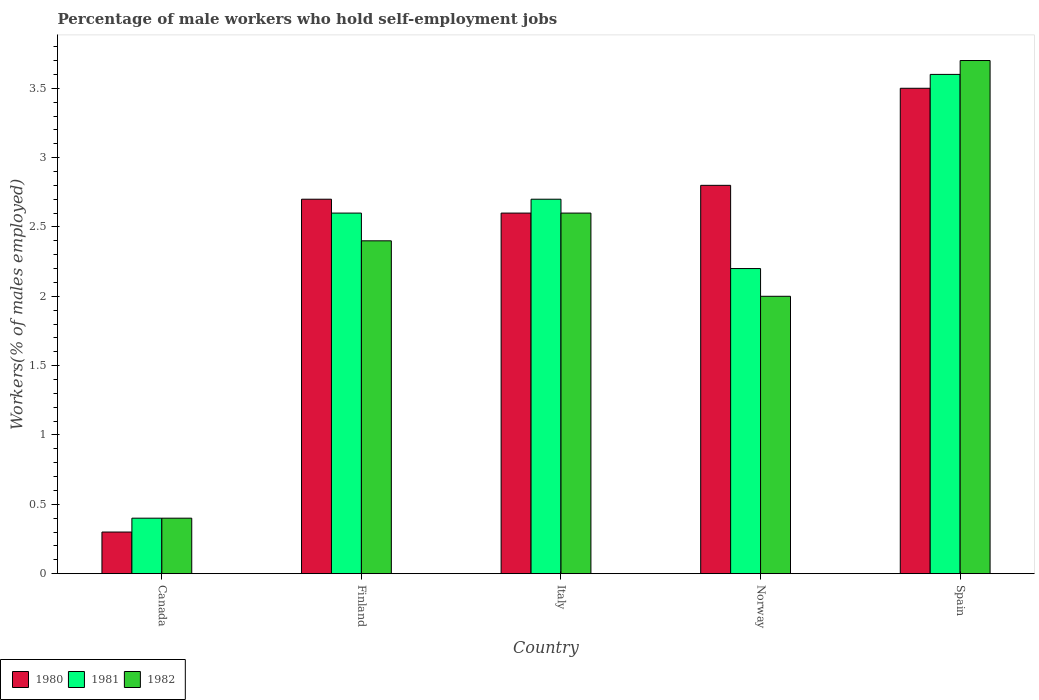How many different coloured bars are there?
Your answer should be compact. 3. Are the number of bars on each tick of the X-axis equal?
Your response must be concise. Yes. How many bars are there on the 4th tick from the left?
Ensure brevity in your answer.  3. What is the percentage of self-employed male workers in 1981 in Canada?
Ensure brevity in your answer.  0.4. Across all countries, what is the maximum percentage of self-employed male workers in 1982?
Give a very brief answer. 3.7. Across all countries, what is the minimum percentage of self-employed male workers in 1982?
Offer a very short reply. 0.4. In which country was the percentage of self-employed male workers in 1981 minimum?
Ensure brevity in your answer.  Canada. What is the total percentage of self-employed male workers in 1980 in the graph?
Provide a succinct answer. 11.9. What is the difference between the percentage of self-employed male workers in 1981 in Canada and that in Spain?
Offer a terse response. -3.2. What is the difference between the percentage of self-employed male workers in 1981 in Spain and the percentage of self-employed male workers in 1982 in Italy?
Provide a succinct answer. 1. What is the average percentage of self-employed male workers in 1981 per country?
Provide a succinct answer. 2.3. What is the difference between the percentage of self-employed male workers of/in 1981 and percentage of self-employed male workers of/in 1982 in Italy?
Ensure brevity in your answer.  0.1. In how many countries, is the percentage of self-employed male workers in 1981 greater than 1.5 %?
Provide a short and direct response. 4. What is the ratio of the percentage of self-employed male workers in 1981 in Italy to that in Norway?
Make the answer very short. 1.23. Is the percentage of self-employed male workers in 1982 in Canada less than that in Norway?
Offer a very short reply. Yes. Is the difference between the percentage of self-employed male workers in 1981 in Italy and Norway greater than the difference between the percentage of self-employed male workers in 1982 in Italy and Norway?
Provide a succinct answer. No. What is the difference between the highest and the second highest percentage of self-employed male workers in 1981?
Make the answer very short. -0.9. What is the difference between the highest and the lowest percentage of self-employed male workers in 1981?
Give a very brief answer. 3.2. What does the 1st bar from the left in Italy represents?
Provide a short and direct response. 1980. Are all the bars in the graph horizontal?
Make the answer very short. No. How many countries are there in the graph?
Keep it short and to the point. 5. What is the difference between two consecutive major ticks on the Y-axis?
Your answer should be very brief. 0.5. Does the graph contain any zero values?
Your answer should be compact. No. Where does the legend appear in the graph?
Provide a short and direct response. Bottom left. How are the legend labels stacked?
Keep it short and to the point. Horizontal. What is the title of the graph?
Your answer should be very brief. Percentage of male workers who hold self-employment jobs. What is the label or title of the Y-axis?
Keep it short and to the point. Workers(% of males employed). What is the Workers(% of males employed) of 1980 in Canada?
Make the answer very short. 0.3. What is the Workers(% of males employed) in 1981 in Canada?
Your answer should be very brief. 0.4. What is the Workers(% of males employed) in 1982 in Canada?
Offer a very short reply. 0.4. What is the Workers(% of males employed) in 1980 in Finland?
Keep it short and to the point. 2.7. What is the Workers(% of males employed) in 1981 in Finland?
Offer a very short reply. 2.6. What is the Workers(% of males employed) in 1982 in Finland?
Make the answer very short. 2.4. What is the Workers(% of males employed) in 1980 in Italy?
Offer a terse response. 2.6. What is the Workers(% of males employed) in 1981 in Italy?
Offer a very short reply. 2.7. What is the Workers(% of males employed) of 1982 in Italy?
Provide a succinct answer. 2.6. What is the Workers(% of males employed) in 1980 in Norway?
Provide a short and direct response. 2.8. What is the Workers(% of males employed) of 1981 in Norway?
Provide a succinct answer. 2.2. What is the Workers(% of males employed) of 1982 in Norway?
Offer a terse response. 2. What is the Workers(% of males employed) in 1980 in Spain?
Your answer should be very brief. 3.5. What is the Workers(% of males employed) in 1981 in Spain?
Your answer should be compact. 3.6. What is the Workers(% of males employed) of 1982 in Spain?
Make the answer very short. 3.7. Across all countries, what is the maximum Workers(% of males employed) of 1980?
Provide a succinct answer. 3.5. Across all countries, what is the maximum Workers(% of males employed) of 1981?
Offer a terse response. 3.6. Across all countries, what is the maximum Workers(% of males employed) of 1982?
Ensure brevity in your answer.  3.7. Across all countries, what is the minimum Workers(% of males employed) in 1980?
Offer a terse response. 0.3. Across all countries, what is the minimum Workers(% of males employed) in 1981?
Offer a very short reply. 0.4. Across all countries, what is the minimum Workers(% of males employed) of 1982?
Make the answer very short. 0.4. What is the total Workers(% of males employed) in 1980 in the graph?
Ensure brevity in your answer.  11.9. What is the total Workers(% of males employed) in 1982 in the graph?
Provide a short and direct response. 11.1. What is the difference between the Workers(% of males employed) in 1980 in Canada and that in Finland?
Ensure brevity in your answer.  -2.4. What is the difference between the Workers(% of males employed) in 1981 in Canada and that in Finland?
Provide a succinct answer. -2.2. What is the difference between the Workers(% of males employed) in 1981 in Canada and that in Italy?
Offer a very short reply. -2.3. What is the difference between the Workers(% of males employed) in 1982 in Canada and that in Italy?
Make the answer very short. -2.2. What is the difference between the Workers(% of males employed) of 1981 in Canada and that in Norway?
Your answer should be very brief. -1.8. What is the difference between the Workers(% of males employed) in 1981 in Canada and that in Spain?
Provide a succinct answer. -3.2. What is the difference between the Workers(% of males employed) in 1982 in Canada and that in Spain?
Your answer should be compact. -3.3. What is the difference between the Workers(% of males employed) of 1980 in Finland and that in Italy?
Provide a short and direct response. 0.1. What is the difference between the Workers(% of males employed) in 1981 in Finland and that in Italy?
Ensure brevity in your answer.  -0.1. What is the difference between the Workers(% of males employed) of 1980 in Finland and that in Norway?
Your answer should be very brief. -0.1. What is the difference between the Workers(% of males employed) in 1982 in Finland and that in Norway?
Offer a very short reply. 0.4. What is the difference between the Workers(% of males employed) of 1980 in Finland and that in Spain?
Give a very brief answer. -0.8. What is the difference between the Workers(% of males employed) in 1981 in Finland and that in Spain?
Ensure brevity in your answer.  -1. What is the difference between the Workers(% of males employed) in 1982 in Finland and that in Spain?
Your answer should be compact. -1.3. What is the difference between the Workers(% of males employed) in 1981 in Italy and that in Norway?
Provide a succinct answer. 0.5. What is the difference between the Workers(% of males employed) in 1982 in Italy and that in Norway?
Give a very brief answer. 0.6. What is the difference between the Workers(% of males employed) in 1981 in Italy and that in Spain?
Your response must be concise. -0.9. What is the difference between the Workers(% of males employed) in 1982 in Italy and that in Spain?
Ensure brevity in your answer.  -1.1. What is the difference between the Workers(% of males employed) in 1980 in Canada and the Workers(% of males employed) in 1981 in Norway?
Make the answer very short. -1.9. What is the difference between the Workers(% of males employed) in 1980 in Canada and the Workers(% of males employed) in 1982 in Norway?
Make the answer very short. -1.7. What is the difference between the Workers(% of males employed) of 1981 in Canada and the Workers(% of males employed) of 1982 in Norway?
Offer a very short reply. -1.6. What is the difference between the Workers(% of males employed) of 1980 in Canada and the Workers(% of males employed) of 1982 in Spain?
Make the answer very short. -3.4. What is the difference between the Workers(% of males employed) of 1981 in Canada and the Workers(% of males employed) of 1982 in Spain?
Keep it short and to the point. -3.3. What is the difference between the Workers(% of males employed) in 1981 in Finland and the Workers(% of males employed) in 1982 in Italy?
Make the answer very short. 0. What is the difference between the Workers(% of males employed) in 1981 in Finland and the Workers(% of males employed) in 1982 in Norway?
Offer a terse response. 0.6. What is the difference between the Workers(% of males employed) of 1980 in Finland and the Workers(% of males employed) of 1982 in Spain?
Offer a terse response. -1. What is the difference between the Workers(% of males employed) of 1981 in Finland and the Workers(% of males employed) of 1982 in Spain?
Offer a very short reply. -1.1. What is the difference between the Workers(% of males employed) in 1980 in Italy and the Workers(% of males employed) in 1982 in Norway?
Ensure brevity in your answer.  0.6. What is the difference between the Workers(% of males employed) in 1980 in Italy and the Workers(% of males employed) in 1982 in Spain?
Ensure brevity in your answer.  -1.1. What is the difference between the Workers(% of males employed) of 1980 in Norway and the Workers(% of males employed) of 1981 in Spain?
Your response must be concise. -0.8. What is the average Workers(% of males employed) in 1980 per country?
Provide a short and direct response. 2.38. What is the average Workers(% of males employed) in 1982 per country?
Ensure brevity in your answer.  2.22. What is the difference between the Workers(% of males employed) of 1980 and Workers(% of males employed) of 1982 in Canada?
Your response must be concise. -0.1. What is the difference between the Workers(% of males employed) in 1980 and Workers(% of males employed) in 1981 in Italy?
Your answer should be very brief. -0.1. What is the difference between the Workers(% of males employed) in 1980 and Workers(% of males employed) in 1982 in Italy?
Offer a terse response. 0. What is the difference between the Workers(% of males employed) of 1980 and Workers(% of males employed) of 1981 in Norway?
Ensure brevity in your answer.  0.6. What is the difference between the Workers(% of males employed) in 1981 and Workers(% of males employed) in 1982 in Norway?
Give a very brief answer. 0.2. What is the ratio of the Workers(% of males employed) of 1980 in Canada to that in Finland?
Provide a short and direct response. 0.11. What is the ratio of the Workers(% of males employed) of 1981 in Canada to that in Finland?
Your answer should be compact. 0.15. What is the ratio of the Workers(% of males employed) in 1982 in Canada to that in Finland?
Make the answer very short. 0.17. What is the ratio of the Workers(% of males employed) of 1980 in Canada to that in Italy?
Ensure brevity in your answer.  0.12. What is the ratio of the Workers(% of males employed) of 1981 in Canada to that in Italy?
Provide a succinct answer. 0.15. What is the ratio of the Workers(% of males employed) in 1982 in Canada to that in Italy?
Provide a succinct answer. 0.15. What is the ratio of the Workers(% of males employed) of 1980 in Canada to that in Norway?
Your answer should be very brief. 0.11. What is the ratio of the Workers(% of males employed) in 1981 in Canada to that in Norway?
Keep it short and to the point. 0.18. What is the ratio of the Workers(% of males employed) of 1982 in Canada to that in Norway?
Ensure brevity in your answer.  0.2. What is the ratio of the Workers(% of males employed) of 1980 in Canada to that in Spain?
Your answer should be very brief. 0.09. What is the ratio of the Workers(% of males employed) in 1982 in Canada to that in Spain?
Offer a terse response. 0.11. What is the ratio of the Workers(% of males employed) of 1980 in Finland to that in Italy?
Your answer should be very brief. 1.04. What is the ratio of the Workers(% of males employed) in 1982 in Finland to that in Italy?
Provide a short and direct response. 0.92. What is the ratio of the Workers(% of males employed) of 1980 in Finland to that in Norway?
Offer a terse response. 0.96. What is the ratio of the Workers(% of males employed) of 1981 in Finland to that in Norway?
Provide a succinct answer. 1.18. What is the ratio of the Workers(% of males employed) in 1980 in Finland to that in Spain?
Give a very brief answer. 0.77. What is the ratio of the Workers(% of males employed) in 1981 in Finland to that in Spain?
Your response must be concise. 0.72. What is the ratio of the Workers(% of males employed) of 1982 in Finland to that in Spain?
Offer a terse response. 0.65. What is the ratio of the Workers(% of males employed) in 1981 in Italy to that in Norway?
Provide a short and direct response. 1.23. What is the ratio of the Workers(% of males employed) in 1982 in Italy to that in Norway?
Provide a succinct answer. 1.3. What is the ratio of the Workers(% of males employed) in 1980 in Italy to that in Spain?
Keep it short and to the point. 0.74. What is the ratio of the Workers(% of males employed) in 1981 in Italy to that in Spain?
Ensure brevity in your answer.  0.75. What is the ratio of the Workers(% of males employed) in 1982 in Italy to that in Spain?
Give a very brief answer. 0.7. What is the ratio of the Workers(% of males employed) of 1980 in Norway to that in Spain?
Give a very brief answer. 0.8. What is the ratio of the Workers(% of males employed) of 1981 in Norway to that in Spain?
Offer a terse response. 0.61. What is the ratio of the Workers(% of males employed) in 1982 in Norway to that in Spain?
Keep it short and to the point. 0.54. What is the difference between the highest and the second highest Workers(% of males employed) of 1981?
Your answer should be compact. 0.9. What is the difference between the highest and the second highest Workers(% of males employed) of 1982?
Make the answer very short. 1.1. 